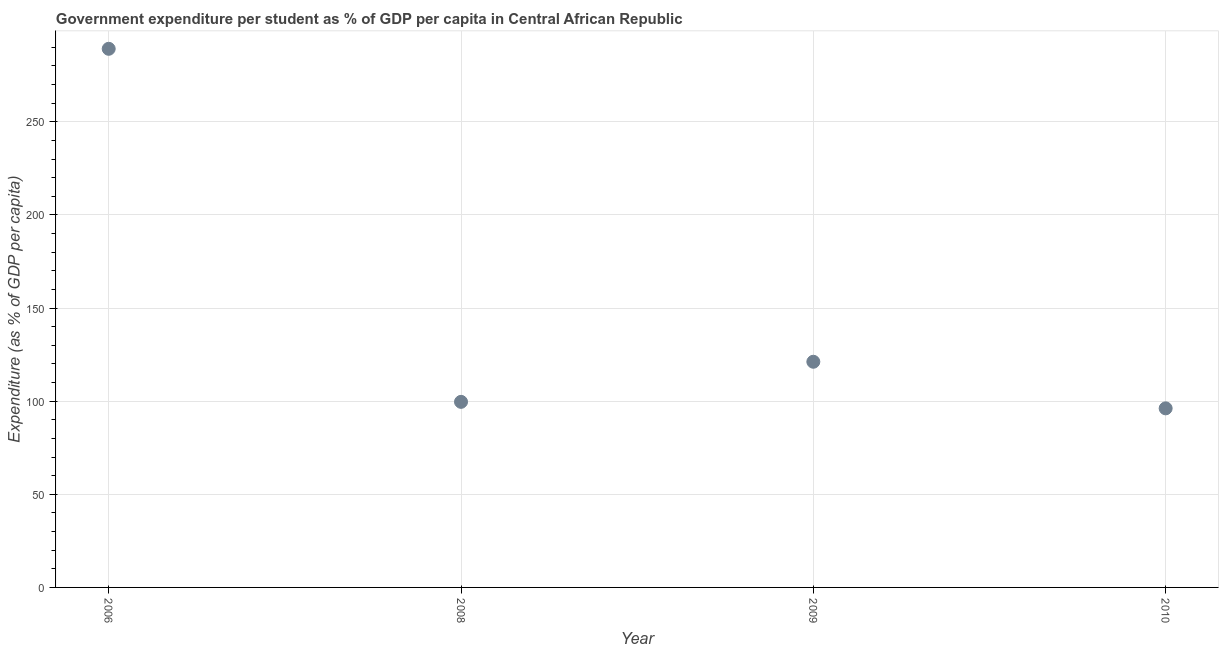What is the government expenditure per student in 2008?
Your answer should be compact. 99.63. Across all years, what is the maximum government expenditure per student?
Offer a terse response. 289.18. Across all years, what is the minimum government expenditure per student?
Give a very brief answer. 96.14. In which year was the government expenditure per student maximum?
Offer a very short reply. 2006. In which year was the government expenditure per student minimum?
Keep it short and to the point. 2010. What is the sum of the government expenditure per student?
Your answer should be very brief. 606.11. What is the difference between the government expenditure per student in 2006 and 2010?
Your answer should be compact. 193.04. What is the average government expenditure per student per year?
Ensure brevity in your answer.  151.53. What is the median government expenditure per student?
Keep it short and to the point. 110.39. In how many years, is the government expenditure per student greater than 200 %?
Give a very brief answer. 1. What is the ratio of the government expenditure per student in 2008 to that in 2010?
Offer a terse response. 1.04. What is the difference between the highest and the second highest government expenditure per student?
Ensure brevity in your answer.  168.02. What is the difference between the highest and the lowest government expenditure per student?
Give a very brief answer. 193.04. In how many years, is the government expenditure per student greater than the average government expenditure per student taken over all years?
Your answer should be very brief. 1. How many years are there in the graph?
Ensure brevity in your answer.  4. What is the difference between two consecutive major ticks on the Y-axis?
Offer a terse response. 50. Does the graph contain any zero values?
Offer a very short reply. No. What is the title of the graph?
Your response must be concise. Government expenditure per student as % of GDP per capita in Central African Republic. What is the label or title of the Y-axis?
Your answer should be compact. Expenditure (as % of GDP per capita). What is the Expenditure (as % of GDP per capita) in 2006?
Your answer should be compact. 289.18. What is the Expenditure (as % of GDP per capita) in 2008?
Give a very brief answer. 99.63. What is the Expenditure (as % of GDP per capita) in 2009?
Keep it short and to the point. 121.16. What is the Expenditure (as % of GDP per capita) in 2010?
Provide a short and direct response. 96.14. What is the difference between the Expenditure (as % of GDP per capita) in 2006 and 2008?
Give a very brief answer. 189.55. What is the difference between the Expenditure (as % of GDP per capita) in 2006 and 2009?
Make the answer very short. 168.02. What is the difference between the Expenditure (as % of GDP per capita) in 2006 and 2010?
Your answer should be compact. 193.04. What is the difference between the Expenditure (as % of GDP per capita) in 2008 and 2009?
Give a very brief answer. -21.52. What is the difference between the Expenditure (as % of GDP per capita) in 2008 and 2010?
Your answer should be very brief. 3.49. What is the difference between the Expenditure (as % of GDP per capita) in 2009 and 2010?
Your answer should be compact. 25.01. What is the ratio of the Expenditure (as % of GDP per capita) in 2006 to that in 2008?
Offer a terse response. 2.9. What is the ratio of the Expenditure (as % of GDP per capita) in 2006 to that in 2009?
Make the answer very short. 2.39. What is the ratio of the Expenditure (as % of GDP per capita) in 2006 to that in 2010?
Your response must be concise. 3.01. What is the ratio of the Expenditure (as % of GDP per capita) in 2008 to that in 2009?
Offer a terse response. 0.82. What is the ratio of the Expenditure (as % of GDP per capita) in 2008 to that in 2010?
Offer a very short reply. 1.04. What is the ratio of the Expenditure (as % of GDP per capita) in 2009 to that in 2010?
Offer a terse response. 1.26. 